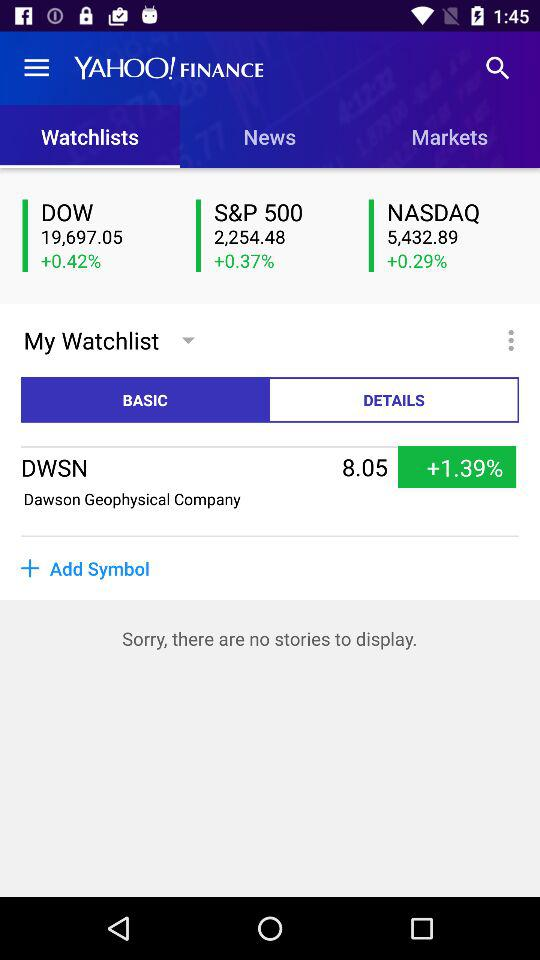What is the NASDAQ value? The NASDAQ value is 5,432.89. 